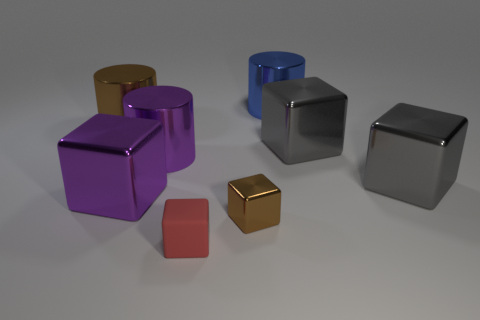The cylinder that is the same color as the small metallic block is what size?
Provide a succinct answer. Large. Are there any other things that have the same material as the small red cube?
Your answer should be very brief. No. There is a cylinder that is behind the brown object that is left of the big cube on the left side of the small red thing; what is its material?
Give a very brief answer. Metal. Is the large block that is left of the big blue cylinder made of the same material as the brown thing to the right of the large brown metal object?
Offer a terse response. Yes. There is a thing that is both on the right side of the purple metallic block and to the left of the small rubber cube; what is its size?
Offer a very short reply. Large. There is a brown object that is the same size as the red matte cube; what material is it?
Offer a terse response. Metal. There is a large metallic cylinder in front of the shiny cylinder that is left of the large purple cylinder; how many cubes are right of it?
Your answer should be very brief. 4. There is a metallic cylinder on the right side of the tiny brown metal thing; does it have the same color as the big metallic block left of the big blue object?
Give a very brief answer. No. What color is the thing that is both to the left of the tiny matte thing and right of the big purple cube?
Make the answer very short. Purple. How many purple metallic things are the same size as the blue thing?
Your response must be concise. 2. 